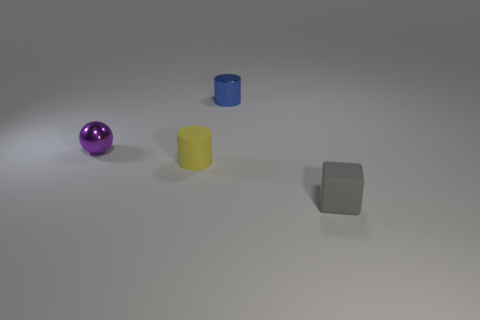The purple shiny thing is what shape?
Your answer should be compact. Sphere. How many things are made of the same material as the gray block?
Your response must be concise. 1. There is a matte cylinder; is it the same color as the small metallic thing that is behind the purple thing?
Your answer should be compact. No. What number of purple cylinders are there?
Give a very brief answer. 0. Is there a cube that has the same color as the tiny rubber cylinder?
Give a very brief answer. No. What color is the small rubber object that is right of the cylinder in front of the small metallic thing left of the tiny blue cylinder?
Provide a succinct answer. Gray. Are the sphere and the small object that is behind the tiny metallic sphere made of the same material?
Ensure brevity in your answer.  Yes. What is the material of the small gray block?
Ensure brevity in your answer.  Rubber. How many other things are made of the same material as the yellow cylinder?
Provide a succinct answer. 1. What shape is the thing that is both behind the yellow cylinder and to the left of the shiny cylinder?
Provide a succinct answer. Sphere. 